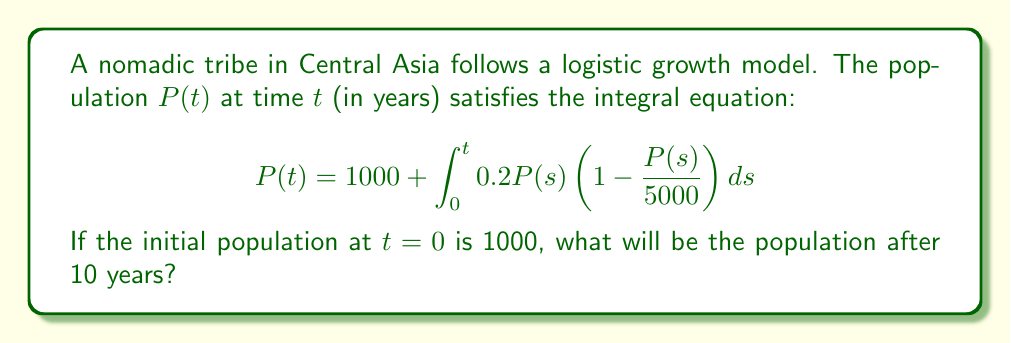Provide a solution to this math problem. To solve this integral equation, we'll use the following steps:

1) First, we recognize this as a Volterra integral equation of the second kind.

2) The equation represents logistic growth with a carrying capacity of 5000 and a growth rate of 0.2.

3) While exact solutions for such equations are complex, we can use numerical methods to approximate the solution.

4) Let's use Euler's method with a step size of 1 year:

   For $i = 0, 1, 2, ..., 9$:
   $$P(i+1) \approx P(i) + 0.2P(i)\left(1 - \frac{P(i)}{5000}\right)$$

5) Starting with $P(0) = 1000$, we calculate:

   $P(1) \approx 1000 + 0.2(1000)(1 - 1000/5000) = 1160$
   $P(2) \approx 1160 + 0.2(1160)(1 - 1160/5000) = 1334.72$
   $P(3) \approx 1334.72 + 0.2(1334.72)(1 - 1334.72/5000) = 1518.95$
   ...

6) Continuing this process for 10 steps, we get:

   $P(10) \approx 2975.62$

7) Rounding to the nearest whole number, as we're dealing with population, we get 2976.
Answer: 2976 